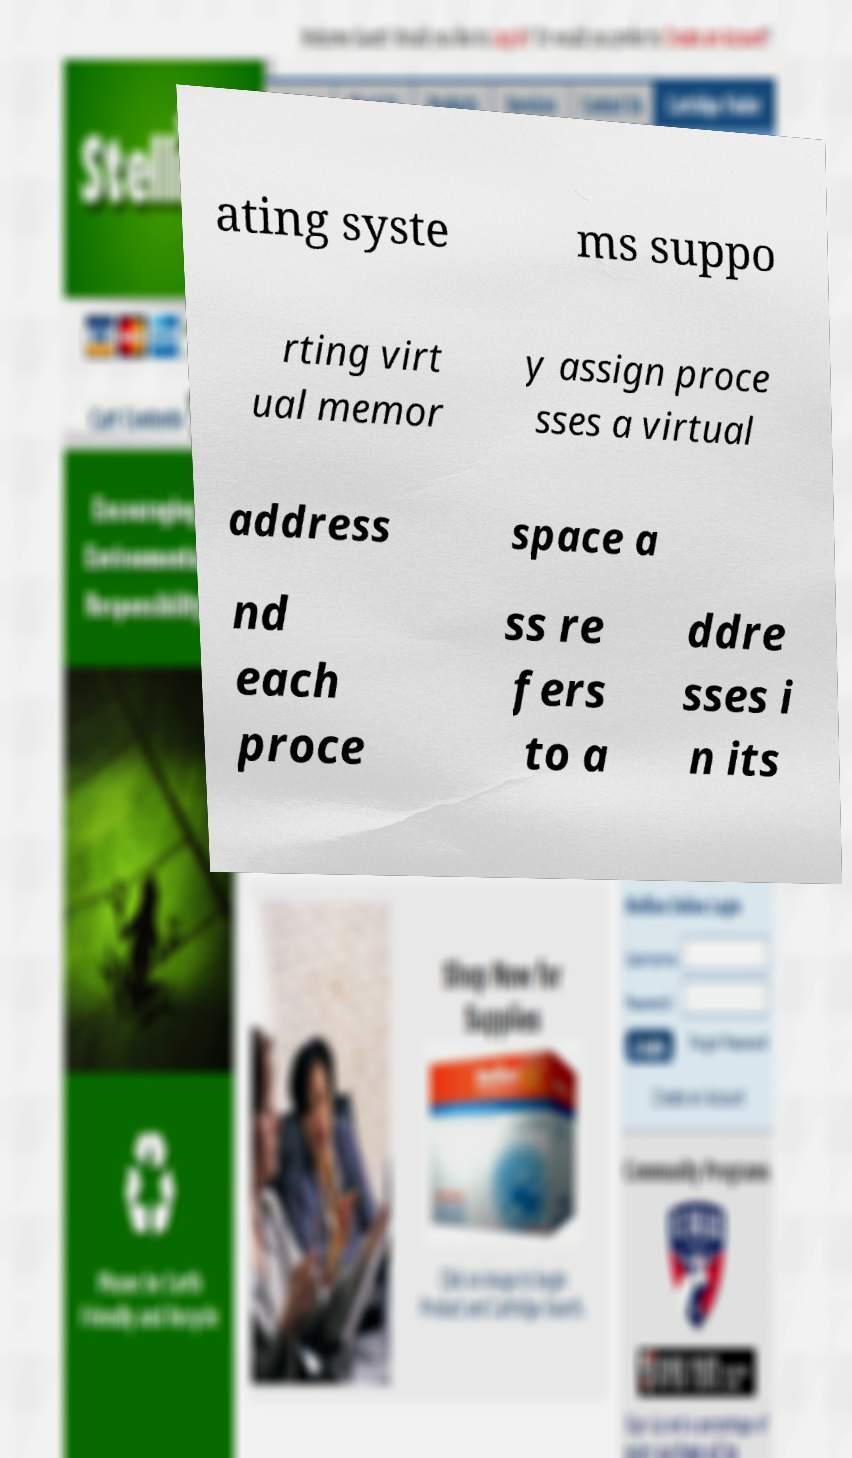Could you assist in decoding the text presented in this image and type it out clearly? ating syste ms suppo rting virt ual memor y assign proce sses a virtual address space a nd each proce ss re fers to a ddre sses i n its 